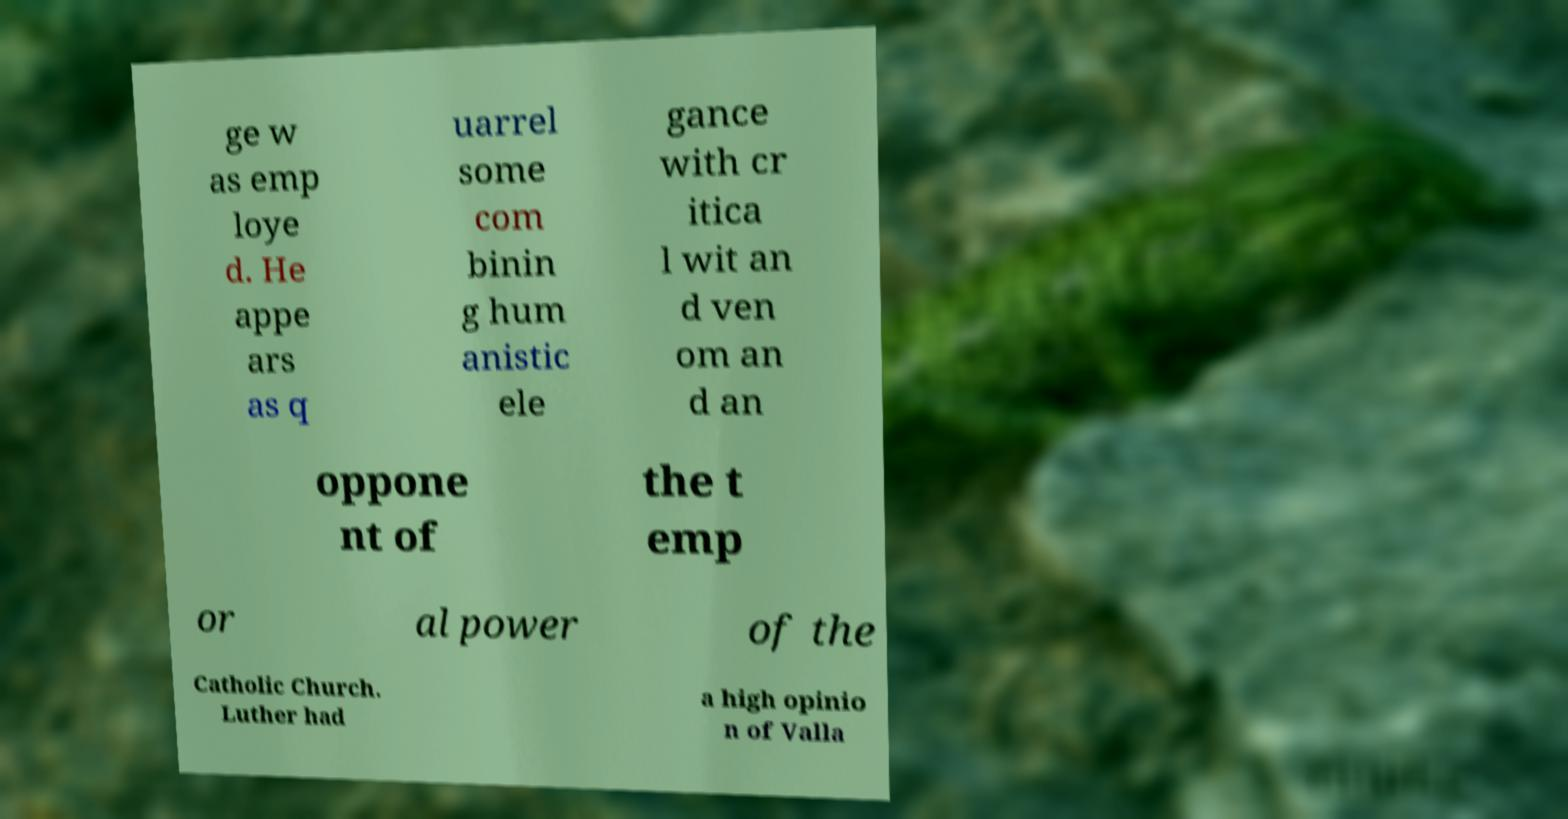For documentation purposes, I need the text within this image transcribed. Could you provide that? ge w as emp loye d. He appe ars as q uarrel some com binin g hum anistic ele gance with cr itica l wit an d ven om an d an oppone nt of the t emp or al power of the Catholic Church. Luther had a high opinio n of Valla 